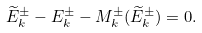Convert formula to latex. <formula><loc_0><loc_0><loc_500><loc_500>\widetilde { E } _ { k } ^ { \pm } - E _ { k } ^ { \pm } - M _ { k } ^ { \pm } ( \widetilde { E } _ { k } ^ { \pm } ) = 0 .</formula> 